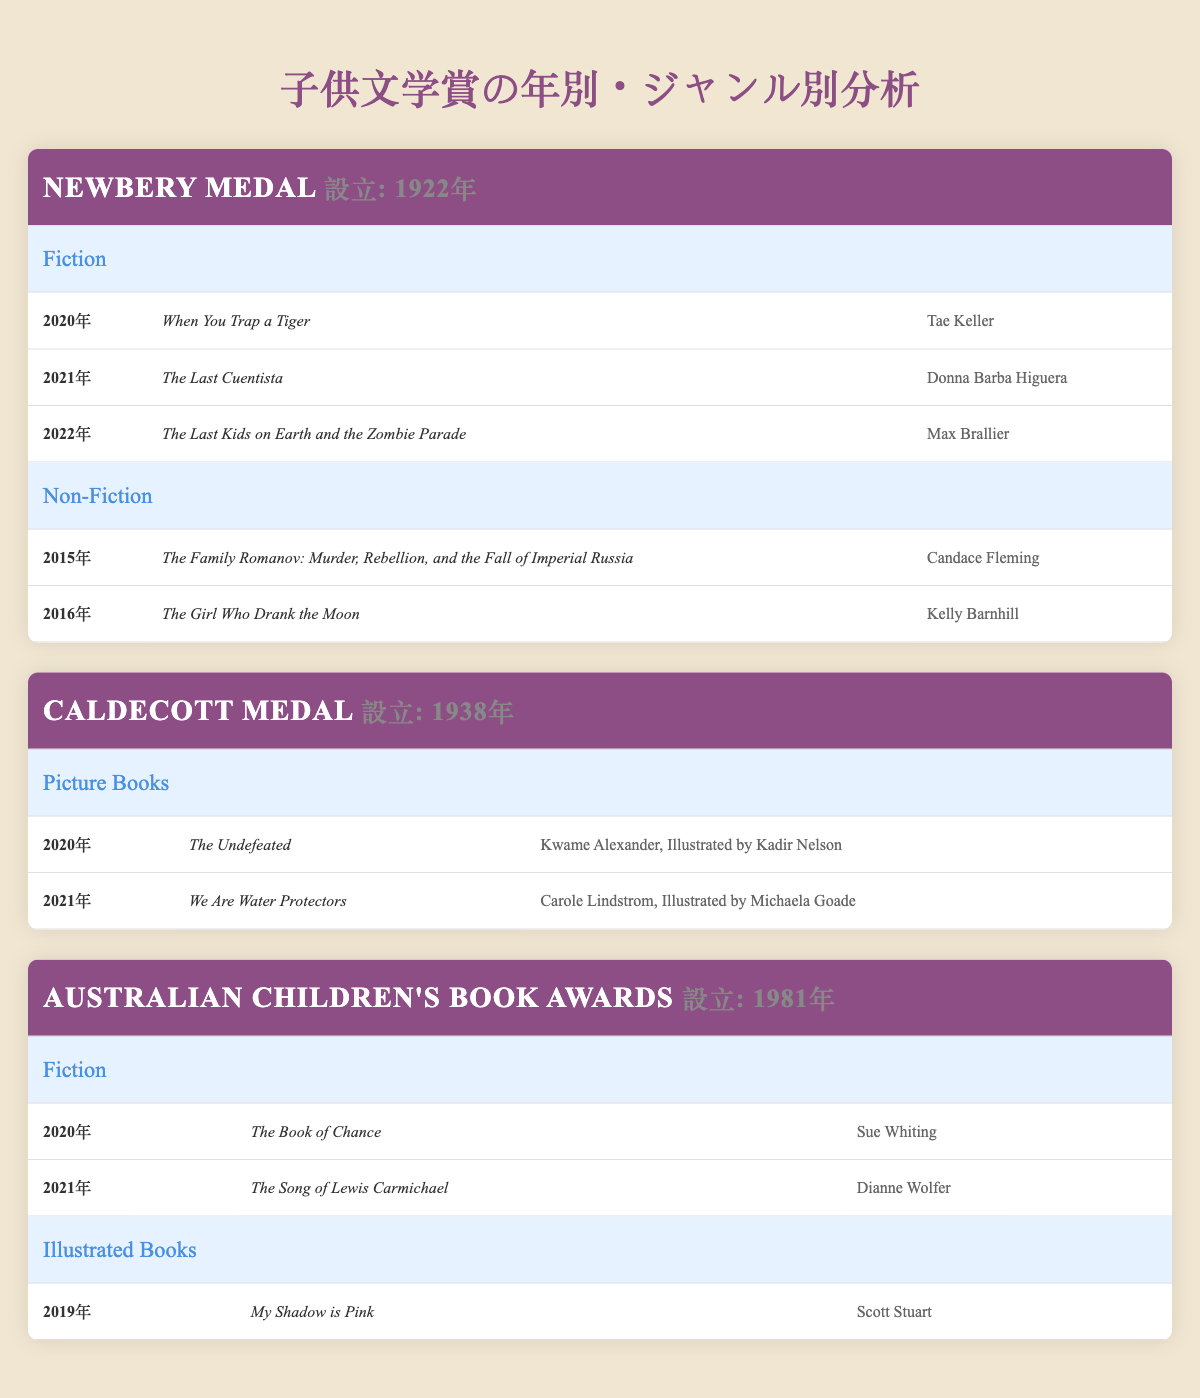What is the winner of the Newbery Medal for Fiction in 2021? The table lists the winners of the Newbery Medal under the Fiction genre. In 2021, the winner is "The Last Cuentista" by Donna Barba Higuera.
Answer: The Last Cuentista How many winners were there for the Caldecott Medal since its establishment? The Caldecott Medal has listed 2 winners in the years 2020 and 2021 in the Picture Books genre.
Answer: 2 Was "My Shadow is Pink" awarded a prize in 2020? The table shows that "My Shadow is Pink" won the Australian Children's Book Awards for Illustrated Books, but it was awarded in 2019, not 2020.
Answer: No Which genre had the most winners in the Newbery Medal? The Newbery Medal for Fiction has 3 winners from 2020 to 2022, while Non-Fiction has 2 winners from 2015 to 2016. Fiction is the genre with the most winners.
Answer: Fiction List all winners of the Australian Children's Book Awards for Fiction. The table specifies that in the Fiction genre for the Australian Children's Book Awards, the winners are "The Book of Chance" by Sue Whiting (2020) and "The Song of Lewis Carmichael" by Dianne Wolfer (2021).
Answer: The Book of Chance, The Song of Lewis Carmichael In what year did the Caldecott Medal recognize "The Undefeated"? According to the table, "The Undefeated" was recognized in 2020 under the Caldecott Medal for Picture Books.
Answer: 2020 What is the total number of winners for the Newbery Medal across both genres? The Newbery Medal has 3 winners in Fiction (2020-2022) and 2 winners in Non-Fiction (2015-2016), giving a total of 5 winners.
Answer: 5 Is there a winner from the Newbery Medal for Non-Fiction in 2022? The table indicates that the last listed winner for Non-Fiction was in 2016, thus confirming that there is no winner in 2022 for this genre.
Answer: No What was the most recent winner for the Caldecott Medal? The table lists "We Are Water Protectors" as the most recent winner for the Caldecott Medal in 2021.
Answer: We Are Water Protectors 